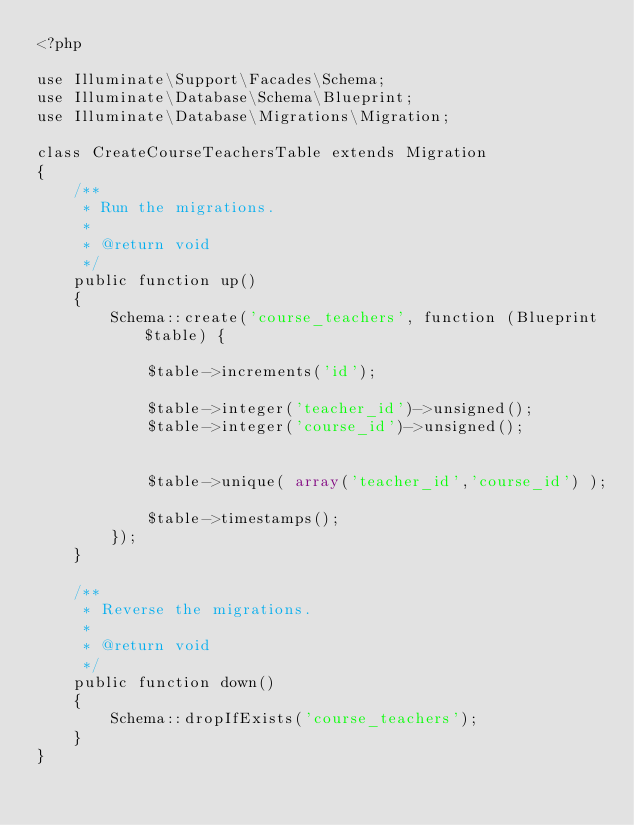Convert code to text. <code><loc_0><loc_0><loc_500><loc_500><_PHP_><?php

use Illuminate\Support\Facades\Schema;
use Illuminate\Database\Schema\Blueprint;
use Illuminate\Database\Migrations\Migration;

class CreateCourseTeachersTable extends Migration
{
    /**
     * Run the migrations.
     *
     * @return void
     */
    public function up()
    {
        Schema::create('course_teachers', function (Blueprint $table) {

            $table->increments('id');

            $table->integer('teacher_id')->unsigned();
            $table->integer('course_id')->unsigned();


            $table->unique( array('teacher_id','course_id') );

            $table->timestamps();
        });
    }

    /**
     * Reverse the migrations.
     *
     * @return void
     */
    public function down()
    {
        Schema::dropIfExists('course_teachers');
    }
}
</code> 